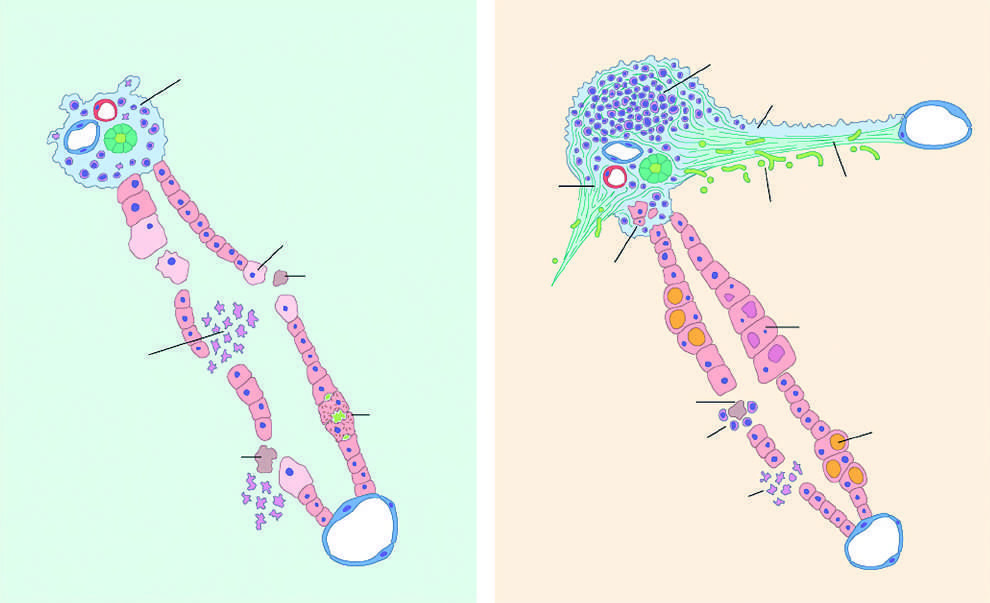s there very little portal mononuclear infiltration in acute hepatitis or sometimes none at all?
Answer the question using a single word or phrase. Yes 